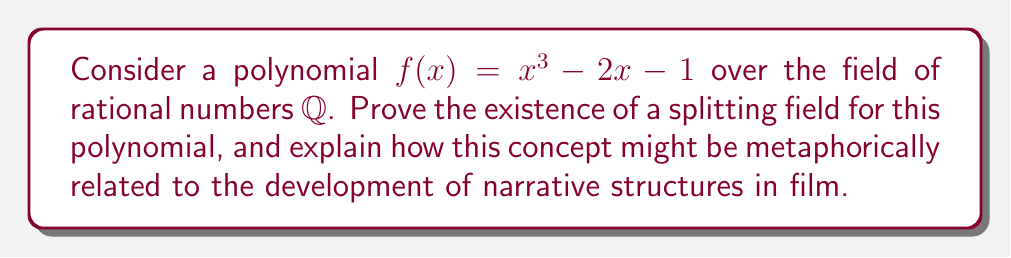Could you help me with this problem? Let's approach this proof step-by-step:

1) First, recall that a splitting field for a polynomial $f(x)$ over a field $F$ is an extension field of $F$ in which $f(x)$ factors completely into linear factors.

2) To prove the existence of a splitting field for $f(x) = x^3 - 2x - 1$ over $\mathbb{Q}$, we can construct it:

   a) Let $\alpha$ be a root of $f(x)$ in some extension field of $\mathbb{Q}$.
   
   b) Consider the field $\mathbb{Q}(\alpha)$ obtained by adjoining $\alpha$ to $\mathbb{Q}$.

3) In $\mathbb{Q}(\alpha)$, $f(x)$ factors as:

   $f(x) = (x - \alpha)(x^2 + \alpha x + (\alpha^2 - 2))$

4) Let $\beta$ be a root of $x^2 + \alpha x + (\alpha^2 - 2)$ in some extension of $\mathbb{Q}(\alpha)$.

5) Consider the field $\mathbb{Q}(\alpha, \beta)$. In this field, $f(x)$ factors completely:

   $f(x) = (x - \alpha)(x - \beta)(x - (\alpha + \beta))$

6) Therefore, $\mathbb{Q}(\alpha, \beta)$ is a splitting field for $f(x)$ over $\mathbb{Q}$.

Relating this to film studies:
The process of constructing a splitting field is analogous to developing a complex narrative in film. Just as we start with a basic field (the initial story idea) and gradually extend it by adding new elements (characters, subplots) until we have a fully realized narrative where all elements interact and resolve (split completely), the mathematical process builds up a field where all roots of the polynomial can be expressed.
Answer: The splitting field exists and is $\mathbb{Q}(\alpha, \beta)$, where $\alpha$ and $\beta$ are roots of $f(x)$. 